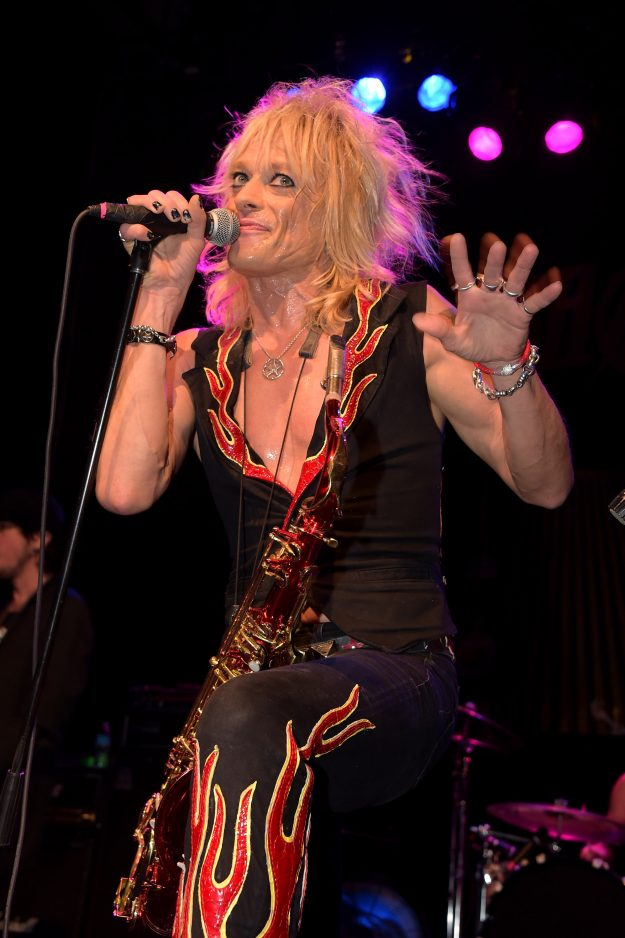What might the performer's hairstyle suggest about their musical influences or era they are inspired by? The performer's voluminous, tousled hairstyle is highly reminiscent of the glam rock era of the 1970s and 1980s, suggesting influences from iconic musicians of that time. This bold and dramatic hairstyle was popularized by bands and performers who sought to merge music with theatrical and flamboyant visuals. By adopting this look, the performer signals a connection to these past musical influences and pays homage to the era's legendary rock figures. This retro hairstyle not only serves as a nod to the past but also positions the performer within a specific tradition of rock music known for its extravagance and larger-than-life personas.  How does the lighting in this image impact the viewer's perception of the performer's stage presence? The dynamic stage lighting, featuring intense blues and purples with occasional pink hues, dramatically enhances the viewer’s perception of the performer’s stage presence. These lighting choices create a visually striking backdrop that makes the performer stand out, emphasizing their movements and amplifying the energy they project. The vibrant colors evoke a sense of excitement and spectacle, key elements of a compelling rock performance. This interplay of light not only highlights the performer's expressive gestures and facial expressions but also sets a theatrical mood, making the concert experience more immersive and visually captivating for the audience. 